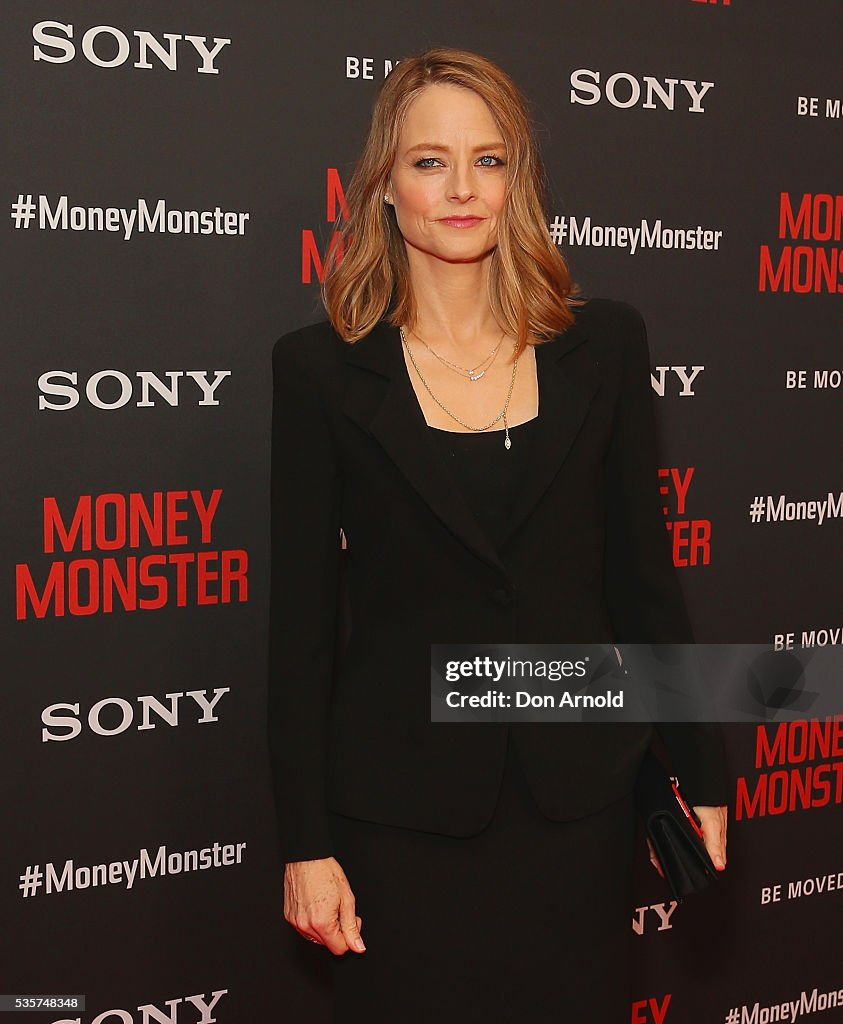What does the lighting suggest about the setting and mood of the event? The lighting in the image appears to be bright and focused, which is typical for red carpet events and media engagements. This type of lighting ensures that individuals are well-illuminated for photographs and video recordings, enhancing their visibility and the clarity of the promotional material. The overall bright, warm lighting contributes to a polished and professional atmosphere, suggesting a lively, celebratory mood appropriate for a high-profile event like a movie premiere. Are there any unique fashion elements in her outfit that stand out? The most notable fashion element in her outfit is its minimalist yet elegant design. The tailored black blazer and top create a sleek silhouette that is both timeless and contemporary. The subtle, layered necklaces add a touch of sophistication without overwhelming the simplicity of the look. This combination of elegance and minimalism is both classic and in line with modern fashion trends, making her outfit stand out for its understated grace. Describe a realistic scenario of what might have just happened before this photo was taken. Just before this photo was taken, the individual might have been preparing backstage, ensuring she looked flawless for the camera. She could have been briefly interacting with event organizers or publicists, receiving last-minute instructions. After stepping onto the red carpet, she might have paused to smile and pose for the photographers, amidst the flashes of cameras and the calls from journalists eager to get a statement or interview. This moment captures her poised and composed, ready to engage with the media and the audience. 